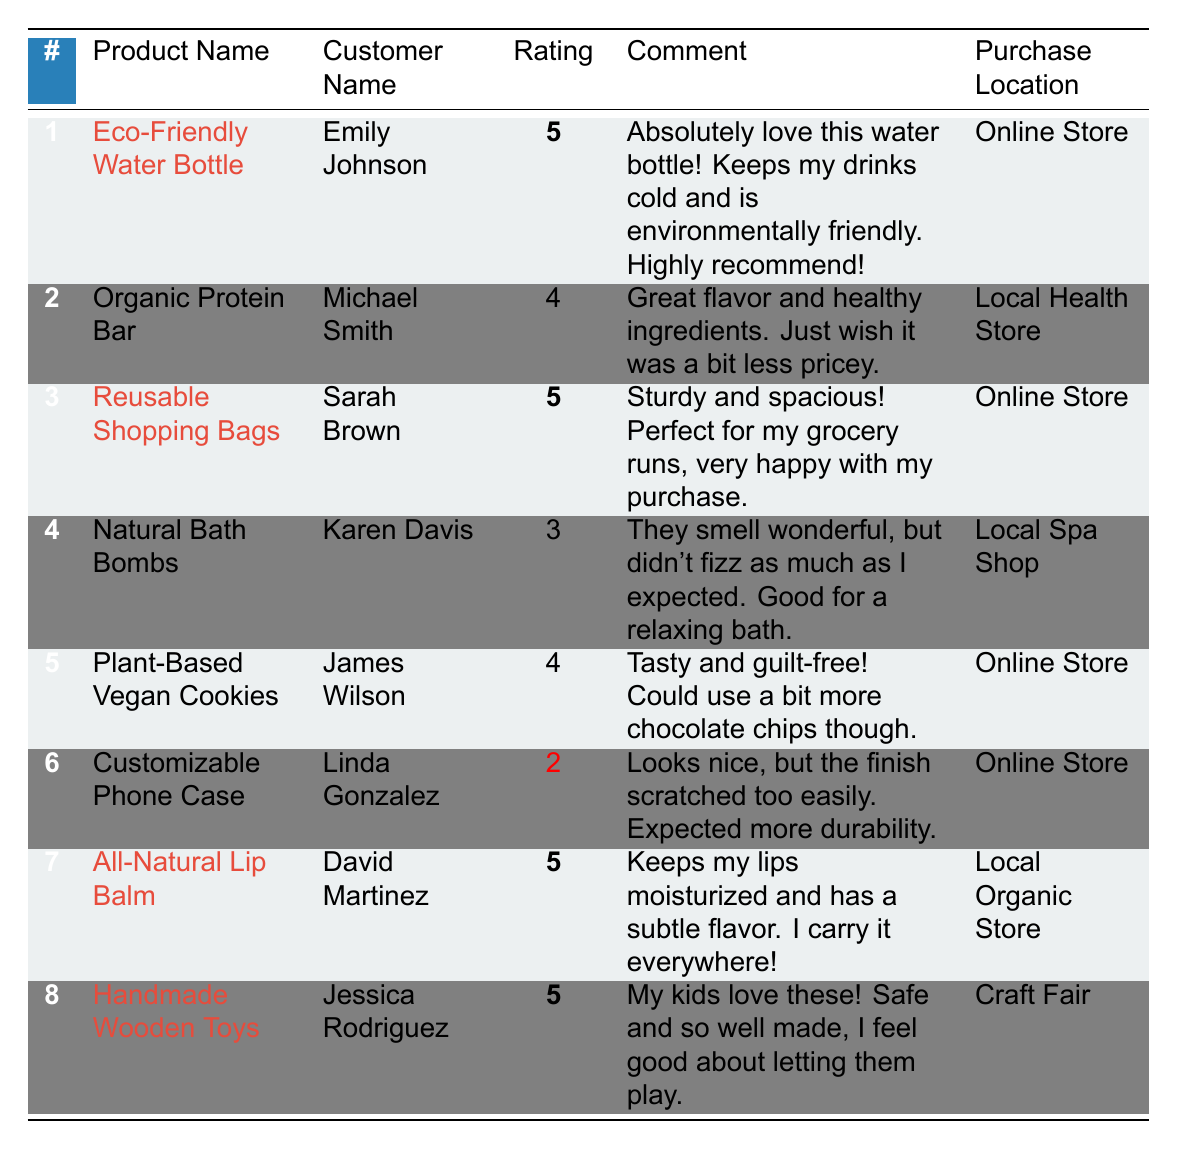What is the highest rating given in the feedback? The highest rating in the table is 5, which is given for the Eco-Friendly Water Bottle, Reusable Shopping Bags, All-Natural Lip Balm, and Handmade Wooden Toys.
Answer: 5 How many customers provided feedback for products in the table? There are 8 unique customer entries in the table, each representing an individual who provided feedback on a product.
Answer: 8 Which product received the lowest rating, and what was the rating? The Customizable Phone Case received the lowest rating of 2.
Answer: Customizable Phone Case, 2 What percentage of the products received a rating of 5? There are 4 products with a rating of 5 out of 8 total products. The percentage is (4/8)*100 = 50%.
Answer: 50% True or False: All products listed were purchased online. Not all products were purchased online; the Handmade Wooden Toys were bought at a Craft Fair and Natural Bath Bombs at a Local Spa Shop.
Answer: False How many products received a rating of 4 or higher? The products with ratings of 4 or higher are Eco-Friendly Water Bottle, Reusable Shopping Bags, Organic Protein Bar, Plant-Based Vegan Cookies, All-Natural Lip Balm, and Handmade Wooden Toys, totaling 6 products.
Answer: 6 What is the average rating of all products listed? To find the average rating, sum the ratings (5 + 4 + 5 + 3 + 4 + 2 + 5 + 5 = 33) and divide by the number of products (33/8 = 4.125). The average rating is approximately 4.13.
Answer: 4.13 Which product has received positive comments along with a high rating? The Eco-Friendly Water Bottle and All-Natural Lip Balm received favorable comments alongside a rating of 5.
Answer: Eco-Friendly Water Bottle, All-Natural Lip Balm Which product had a customer wish for it to be less pricey? The Organic Protein Bar received feedback stating that the customer wished it was a bit less pricey.
Answer: Organic Protein Bar What characteristics did the customer attribute to the Reusable Shopping Bags? The customer described the Reusable Shopping Bags as sturdy and spacious, indicating satisfaction with their performance during grocery runs.
Answer: Sturdy and spacious 